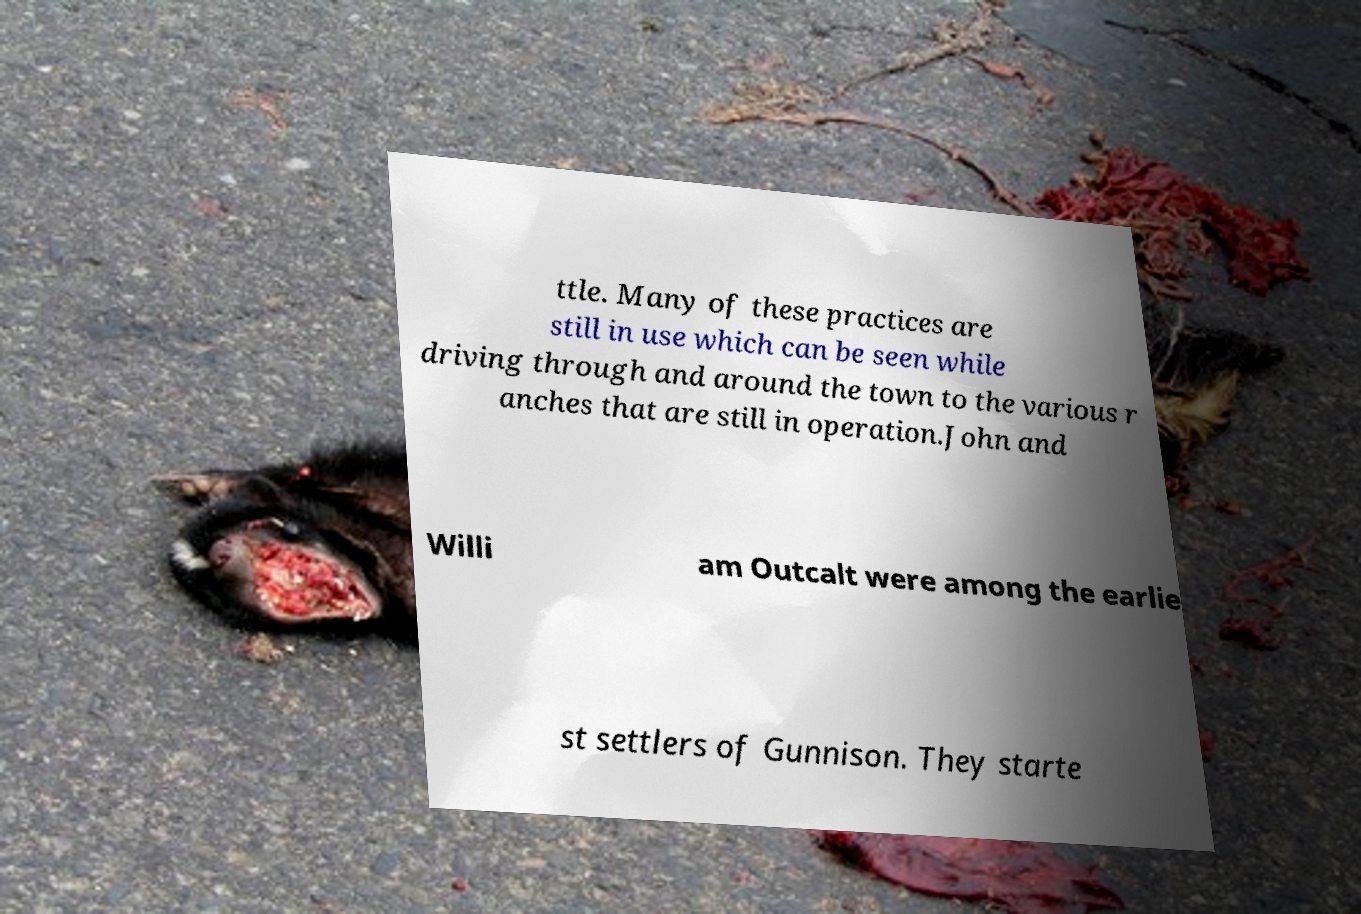Could you assist in decoding the text presented in this image and type it out clearly? ttle. Many of these practices are still in use which can be seen while driving through and around the town to the various r anches that are still in operation.John and Willi am Outcalt were among the earlie st settlers of Gunnison. They starte 